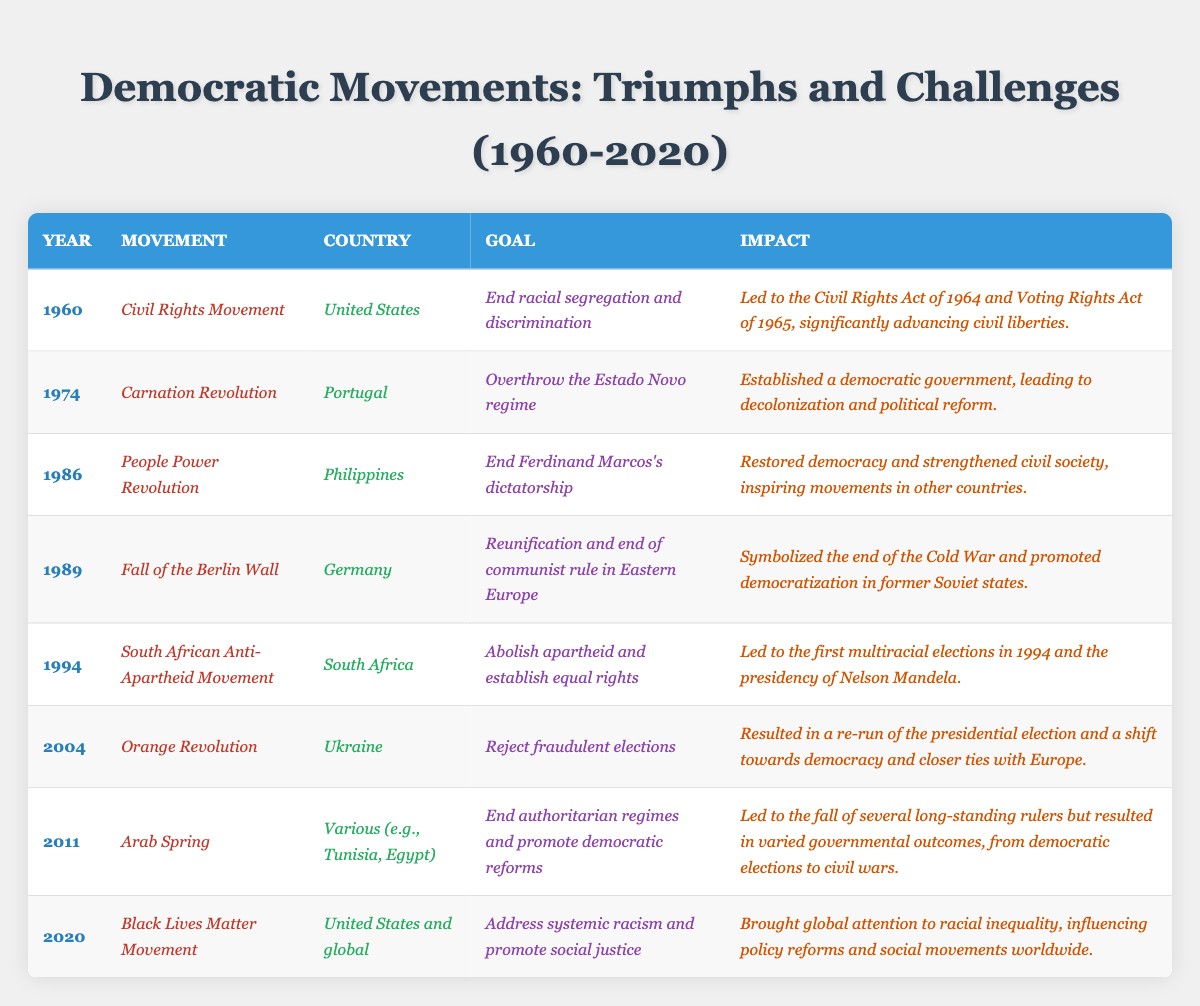What was the goal of the Civil Rights Movement? The table lists the goal associated with the Civil Rights Movement under the "Goal" column for the year 1960, which is to "End racial segregation and discrimination."
Answer: End racial segregation and discrimination Which country experienced the Carnation Revolution? The entry for the year 1974 indicates that the Carnation Revolution occurred in Portugal, as per the "Country" column.
Answer: Portugal How many movements focused on ending authoritarian regimes? The movements that aimed to end authoritarian regimes are the People Power Revolution (1986), Arab Spring (2011), and the Civil Rights Movement (1960), allowing us to count three movements.
Answer: Three movements What significant impact did the Fall of the Berlin Wall have according to the table? The impact recorded for the Fall of the Berlin Wall in 1989 is that it "Symbolized the end of the Cold War and promoted democratization in former Soviet states."
Answer: Symbolized the end of the Cold War and promoted democratization in former Soviet states Did the South African Anti-Apartheid Movement lead to multiracial elections? The entry for the South African Anti-Apartheid Movement in 1994 mentions that it "Led to the first multiracial elections in 1994," indicating the statement is true.
Answer: Yes Which two movements occurred in the 2010s according to the table? The movements listed for the 2010s are the Arab Spring (2011) and the Black Lives Matter Movement (2020), fulfilling the condition of being within the decade.
Answer: Arab Spring and Black Lives Matter Movement After which movement did a prominent political figure like Nelson Mandela become president? The table shows that after the South African Anti-Apartheid Movement in 1994, Nelson Mandela became the president, relating to that specific movement.
Answer: South African Anti-Apartheid Movement What is the chronological order of movements that occurred in the '70s and '80s? The movements in the '70s and '80s are: 1974 - Carnation Revolution; 1986 - People Power Revolution; 1989 - Fall of the Berlin Wall. Arranging them by year provides the chronological order.
Answer: Carnation Revolution, People Power Revolution, Fall of the Berlin Wall Which movement had a global focus, according to the information presented? The Black Lives Matter Movement, listed for the year 2020, is noted to have a global presence, as indicated by the description stating "United States and global."
Answer: Black Lives Matter Movement Is the Arab Spring associated with a positive or negative outcome, based on the table? The entry states that the Arab Spring "Led to the fall of several long-standing rulers but resulted in varied governmental outcomes," implying both positive and negative results.
Answer: Varied outcomes (positive and negative) 